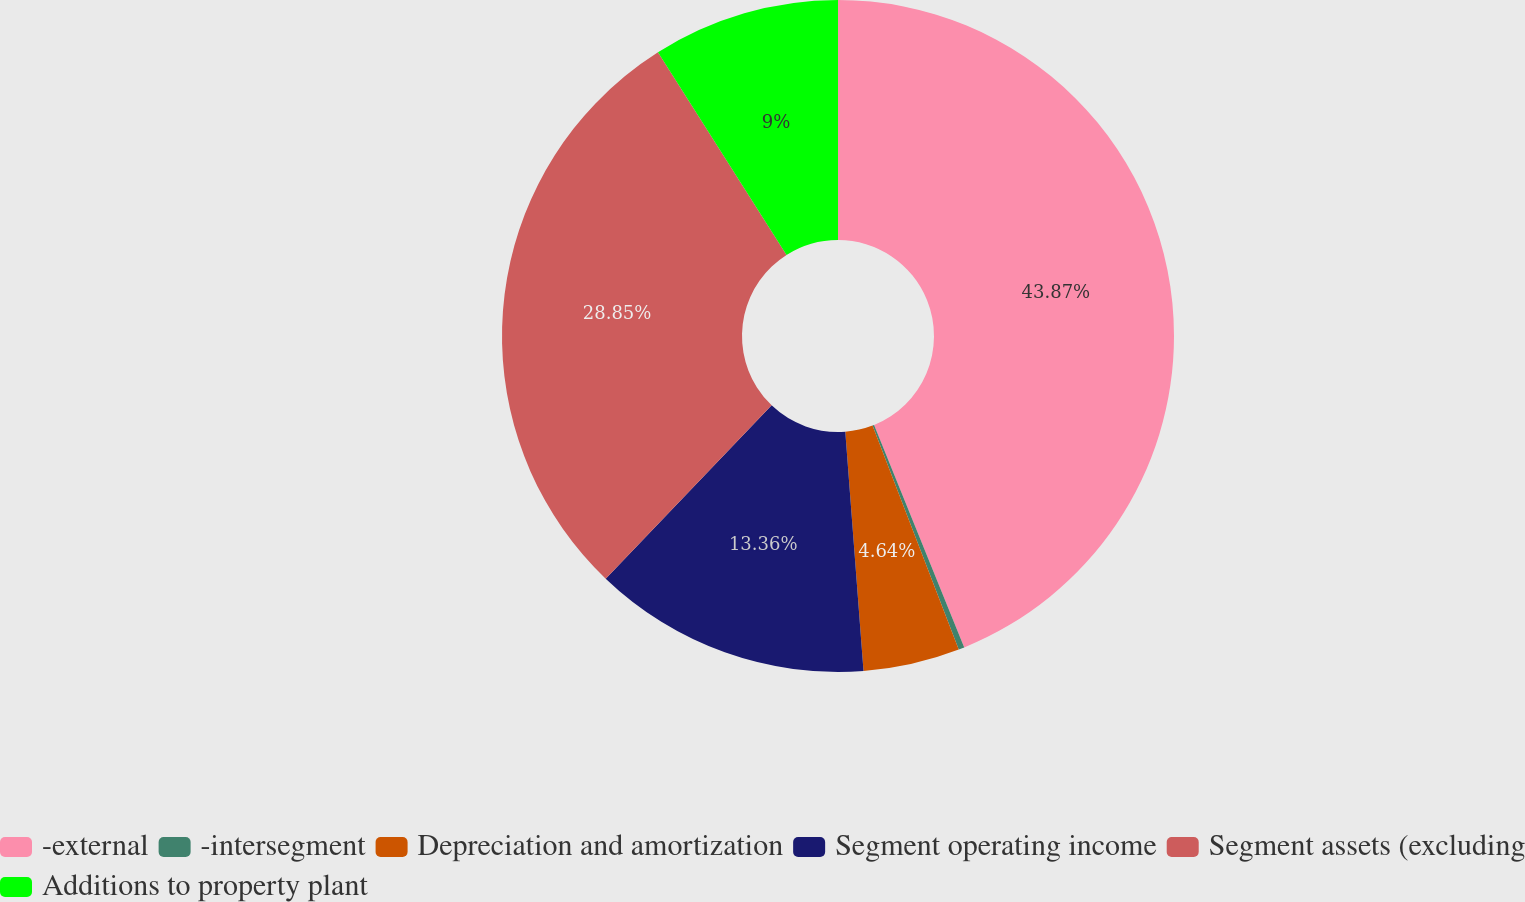Convert chart. <chart><loc_0><loc_0><loc_500><loc_500><pie_chart><fcel>-external<fcel>-intersegment<fcel>Depreciation and amortization<fcel>Segment operating income<fcel>Segment assets (excluding<fcel>Additions to property plant<nl><fcel>43.87%<fcel>0.28%<fcel>4.64%<fcel>13.36%<fcel>28.85%<fcel>9.0%<nl></chart> 